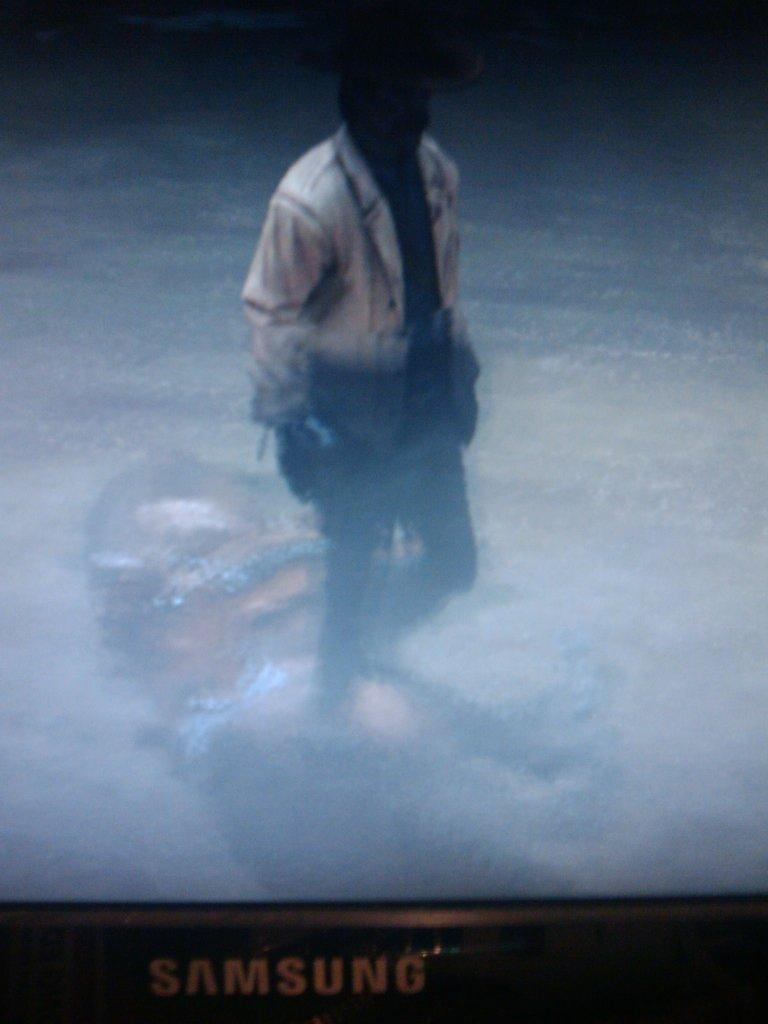What electronic device is present in the image? There is a television in the image. Can you describe the person in the image? There is a person standing in the image. What type of canvas is being used to paint a cave in the image? There is no canvas or cave present in the image; it features a television and a person standing. How many pies are visible on the table in the image? There is no table or pies present in the image; it only features a television and a person standing. 